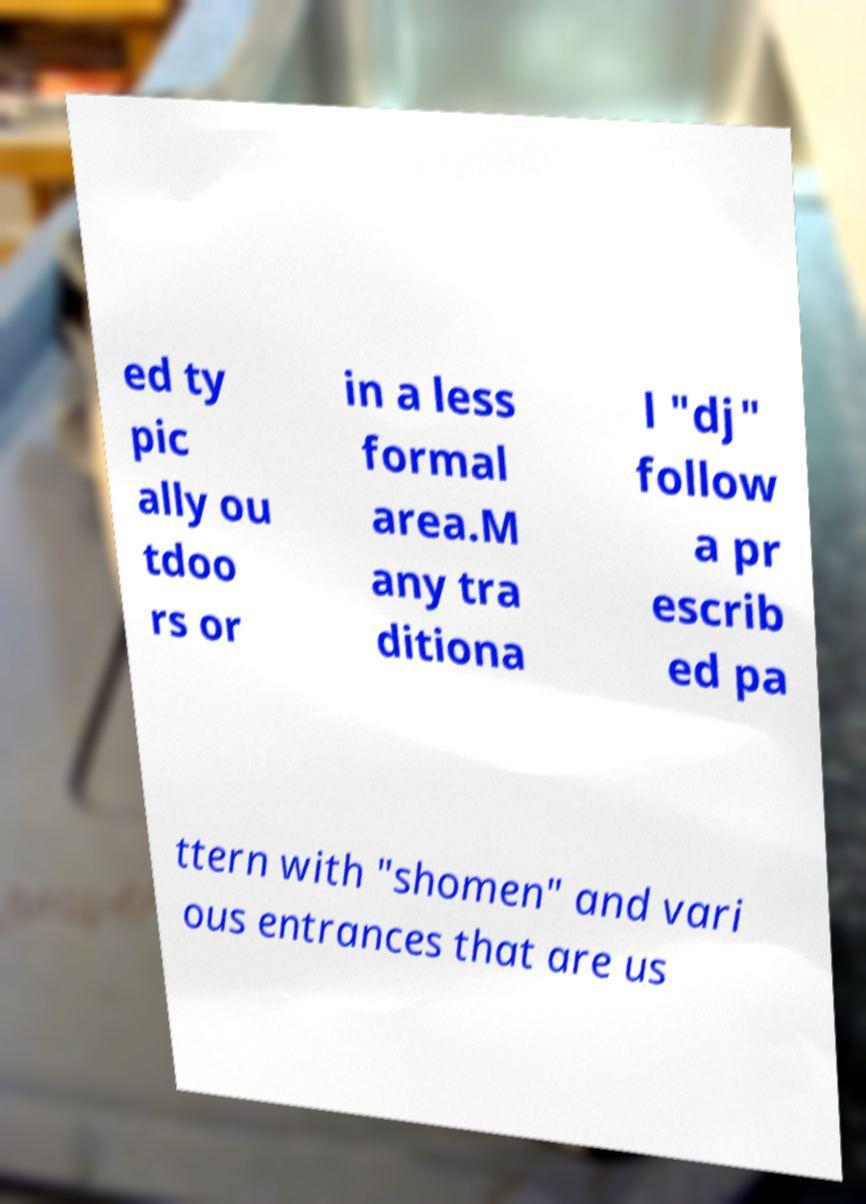Can you read and provide the text displayed in the image?This photo seems to have some interesting text. Can you extract and type it out for me? ed ty pic ally ou tdoo rs or in a less formal area.M any tra ditiona l "dj" follow a pr escrib ed pa ttern with "shomen" and vari ous entrances that are us 